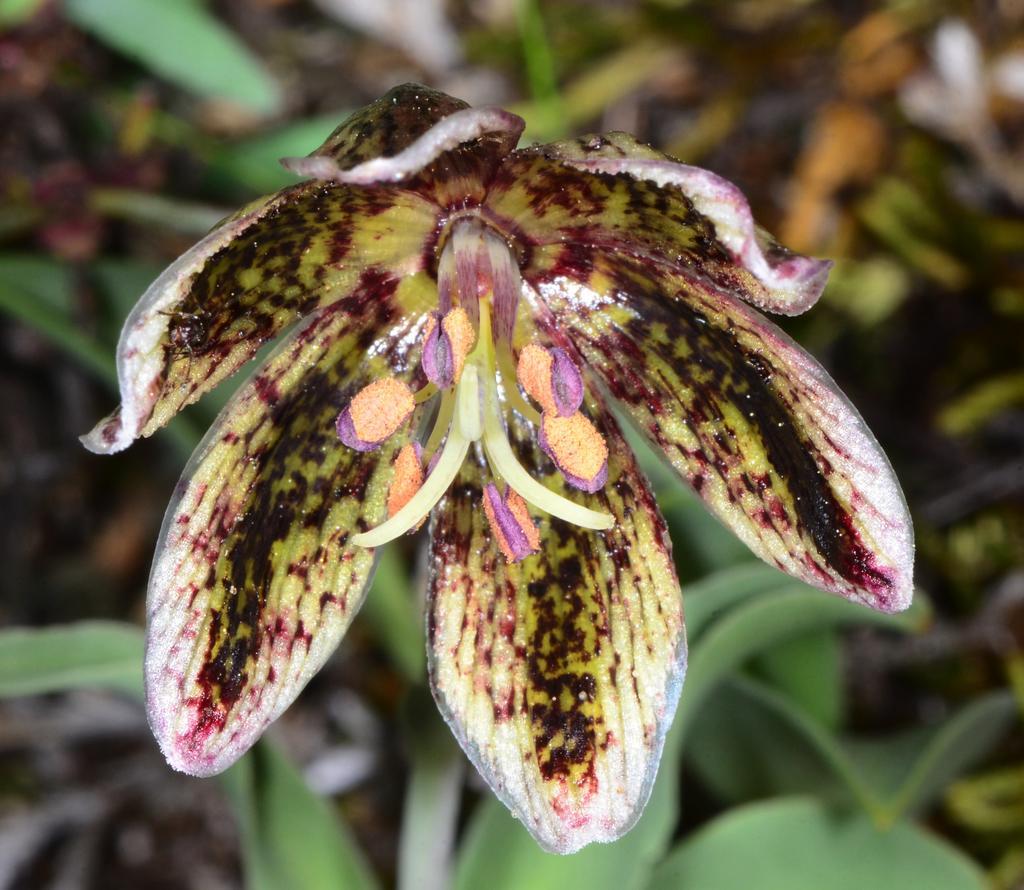Could you give a brief overview of what you see in this image? In this image I can see flower and leaves visible. 